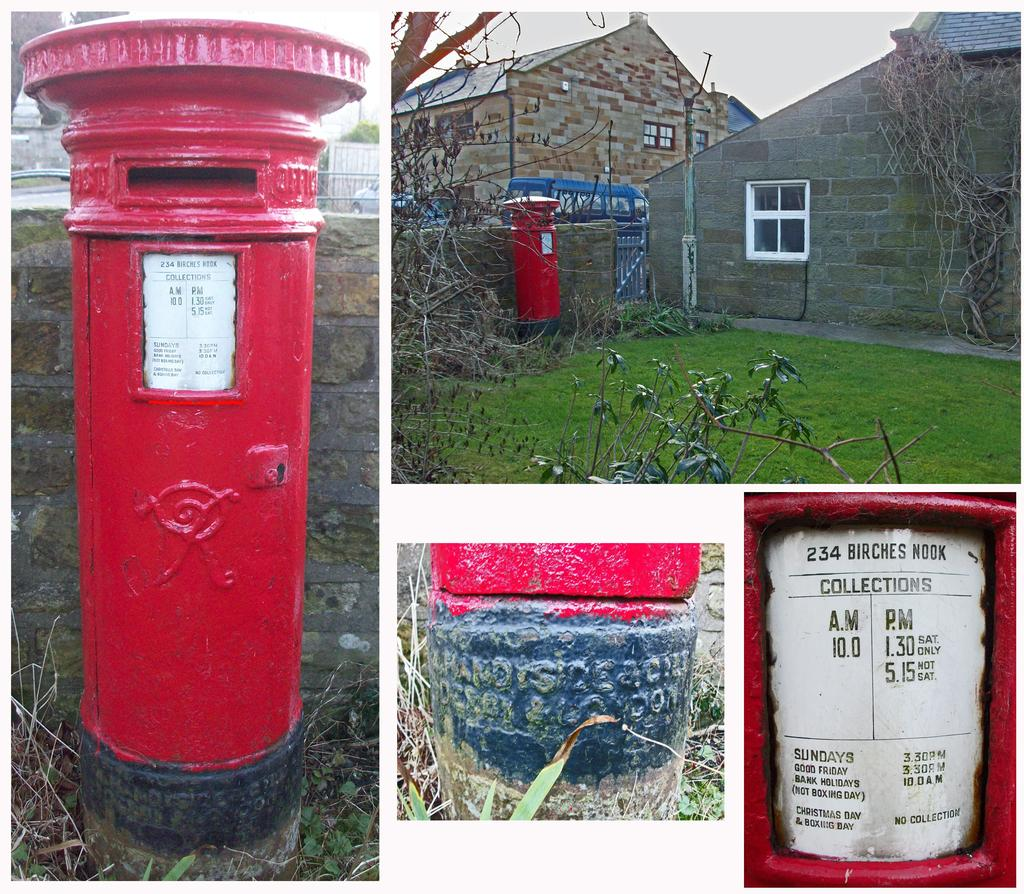What type of objects can be seen in the image? There are hydrants, plants, and poles in the image. What type of vegetation is present in the image? There is grass in the image. What type of structures can be seen in the image? There are houses in the image. What architectural features can be seen on the houses? There are windows in the image. What type of barrier is present in the image? There is a wall in the image. Where are the toys located in the image? There are no toys present in the image. What type of lumber is being used to construct the houses in the image? There is no information about the construction materials of the houses in the image. What type of medical facility can be seen in the image? There is no medical facility, such as a hospital, present in the image. 